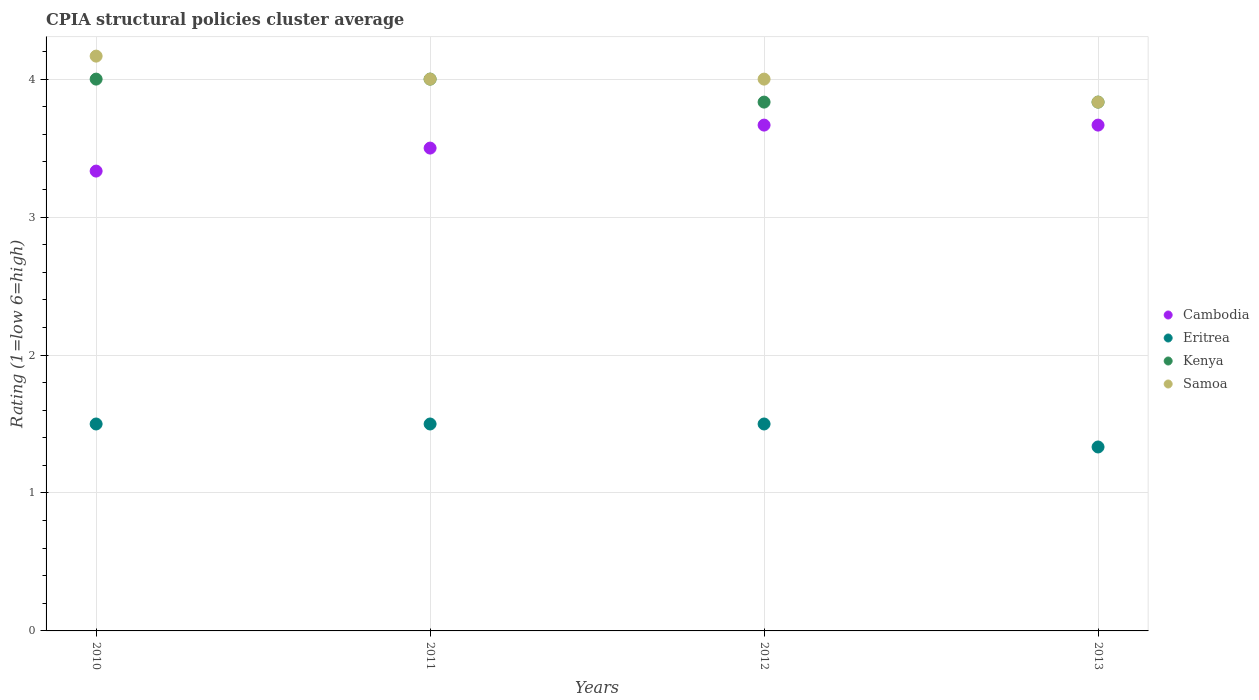How many different coloured dotlines are there?
Give a very brief answer. 4. Is the number of dotlines equal to the number of legend labels?
Your answer should be compact. Yes. What is the CPIA rating in Kenya in 2011?
Provide a succinct answer. 4. Across all years, what is the minimum CPIA rating in Eritrea?
Provide a short and direct response. 1.33. In which year was the CPIA rating in Cambodia maximum?
Give a very brief answer. 2012. In which year was the CPIA rating in Cambodia minimum?
Your response must be concise. 2010. What is the total CPIA rating in Kenya in the graph?
Your answer should be very brief. 15.67. What is the difference between the CPIA rating in Samoa in 2010 and that in 2013?
Your response must be concise. 0.33. What is the difference between the CPIA rating in Cambodia in 2013 and the CPIA rating in Eritrea in 2010?
Keep it short and to the point. 2.17. What is the average CPIA rating in Samoa per year?
Provide a short and direct response. 4. In the year 2012, what is the difference between the CPIA rating in Cambodia and CPIA rating in Samoa?
Give a very brief answer. -0.33. In how many years, is the CPIA rating in Cambodia greater than 0.2?
Ensure brevity in your answer.  4. What is the ratio of the CPIA rating in Samoa in 2012 to that in 2013?
Offer a terse response. 1.04. Is the difference between the CPIA rating in Cambodia in 2012 and 2013 greater than the difference between the CPIA rating in Samoa in 2012 and 2013?
Keep it short and to the point. No. What is the difference between the highest and the second highest CPIA rating in Samoa?
Keep it short and to the point. 0.17. What is the difference between the highest and the lowest CPIA rating in Cambodia?
Give a very brief answer. 0.33. Is it the case that in every year, the sum of the CPIA rating in Eritrea and CPIA rating in Samoa  is greater than the sum of CPIA rating in Kenya and CPIA rating in Cambodia?
Keep it short and to the point. No. Is it the case that in every year, the sum of the CPIA rating in Eritrea and CPIA rating in Kenya  is greater than the CPIA rating in Samoa?
Your answer should be compact. Yes. Is the CPIA rating in Cambodia strictly greater than the CPIA rating in Kenya over the years?
Give a very brief answer. No. How many dotlines are there?
Give a very brief answer. 4. How many years are there in the graph?
Offer a very short reply. 4. Does the graph contain any zero values?
Offer a very short reply. No. Where does the legend appear in the graph?
Offer a very short reply. Center right. How many legend labels are there?
Offer a terse response. 4. How are the legend labels stacked?
Give a very brief answer. Vertical. What is the title of the graph?
Provide a short and direct response. CPIA structural policies cluster average. What is the Rating (1=low 6=high) in Cambodia in 2010?
Your answer should be very brief. 3.33. What is the Rating (1=low 6=high) of Eritrea in 2010?
Keep it short and to the point. 1.5. What is the Rating (1=low 6=high) of Kenya in 2010?
Offer a very short reply. 4. What is the Rating (1=low 6=high) in Samoa in 2010?
Make the answer very short. 4.17. What is the Rating (1=low 6=high) in Cambodia in 2011?
Provide a short and direct response. 3.5. What is the Rating (1=low 6=high) of Cambodia in 2012?
Your answer should be very brief. 3.67. What is the Rating (1=low 6=high) in Eritrea in 2012?
Provide a short and direct response. 1.5. What is the Rating (1=low 6=high) in Kenya in 2012?
Offer a terse response. 3.83. What is the Rating (1=low 6=high) of Samoa in 2012?
Keep it short and to the point. 4. What is the Rating (1=low 6=high) in Cambodia in 2013?
Ensure brevity in your answer.  3.67. What is the Rating (1=low 6=high) of Eritrea in 2013?
Give a very brief answer. 1.33. What is the Rating (1=low 6=high) of Kenya in 2013?
Make the answer very short. 3.83. What is the Rating (1=low 6=high) in Samoa in 2013?
Provide a short and direct response. 3.83. Across all years, what is the maximum Rating (1=low 6=high) of Cambodia?
Provide a succinct answer. 3.67. Across all years, what is the maximum Rating (1=low 6=high) in Samoa?
Offer a terse response. 4.17. Across all years, what is the minimum Rating (1=low 6=high) of Cambodia?
Offer a terse response. 3.33. Across all years, what is the minimum Rating (1=low 6=high) of Eritrea?
Your response must be concise. 1.33. Across all years, what is the minimum Rating (1=low 6=high) in Kenya?
Ensure brevity in your answer.  3.83. Across all years, what is the minimum Rating (1=low 6=high) of Samoa?
Keep it short and to the point. 3.83. What is the total Rating (1=low 6=high) in Cambodia in the graph?
Keep it short and to the point. 14.17. What is the total Rating (1=low 6=high) in Eritrea in the graph?
Your answer should be compact. 5.83. What is the total Rating (1=low 6=high) of Kenya in the graph?
Give a very brief answer. 15.67. What is the total Rating (1=low 6=high) in Samoa in the graph?
Offer a very short reply. 16. What is the difference between the Rating (1=low 6=high) in Cambodia in 2010 and that in 2011?
Provide a short and direct response. -0.17. What is the difference between the Rating (1=low 6=high) in Eritrea in 2010 and that in 2011?
Provide a short and direct response. 0. What is the difference between the Rating (1=low 6=high) in Samoa in 2010 and that in 2011?
Offer a terse response. 0.17. What is the difference between the Rating (1=low 6=high) of Cambodia in 2010 and that in 2012?
Provide a succinct answer. -0.33. What is the difference between the Rating (1=low 6=high) in Eritrea in 2010 and that in 2012?
Provide a succinct answer. 0. What is the difference between the Rating (1=low 6=high) of Samoa in 2010 and that in 2012?
Offer a very short reply. 0.17. What is the difference between the Rating (1=low 6=high) in Cambodia in 2010 and that in 2013?
Offer a terse response. -0.33. What is the difference between the Rating (1=low 6=high) of Kenya in 2010 and that in 2013?
Ensure brevity in your answer.  0.17. What is the difference between the Rating (1=low 6=high) in Cambodia in 2011 and that in 2012?
Keep it short and to the point. -0.17. What is the difference between the Rating (1=low 6=high) of Cambodia in 2011 and that in 2013?
Make the answer very short. -0.17. What is the difference between the Rating (1=low 6=high) in Eritrea in 2011 and that in 2013?
Your answer should be compact. 0.17. What is the difference between the Rating (1=low 6=high) in Kenya in 2011 and that in 2013?
Provide a succinct answer. 0.17. What is the difference between the Rating (1=low 6=high) of Samoa in 2011 and that in 2013?
Make the answer very short. 0.17. What is the difference between the Rating (1=low 6=high) of Cambodia in 2012 and that in 2013?
Provide a succinct answer. 0. What is the difference between the Rating (1=low 6=high) of Kenya in 2012 and that in 2013?
Offer a very short reply. 0. What is the difference between the Rating (1=low 6=high) in Cambodia in 2010 and the Rating (1=low 6=high) in Eritrea in 2011?
Offer a very short reply. 1.83. What is the difference between the Rating (1=low 6=high) in Cambodia in 2010 and the Rating (1=low 6=high) in Samoa in 2011?
Your response must be concise. -0.67. What is the difference between the Rating (1=low 6=high) of Eritrea in 2010 and the Rating (1=low 6=high) of Kenya in 2011?
Give a very brief answer. -2.5. What is the difference between the Rating (1=low 6=high) in Eritrea in 2010 and the Rating (1=low 6=high) in Samoa in 2011?
Your answer should be very brief. -2.5. What is the difference between the Rating (1=low 6=high) in Cambodia in 2010 and the Rating (1=low 6=high) in Eritrea in 2012?
Offer a very short reply. 1.83. What is the difference between the Rating (1=low 6=high) of Eritrea in 2010 and the Rating (1=low 6=high) of Kenya in 2012?
Give a very brief answer. -2.33. What is the difference between the Rating (1=low 6=high) in Kenya in 2010 and the Rating (1=low 6=high) in Samoa in 2012?
Offer a terse response. 0. What is the difference between the Rating (1=low 6=high) in Cambodia in 2010 and the Rating (1=low 6=high) in Eritrea in 2013?
Give a very brief answer. 2. What is the difference between the Rating (1=low 6=high) in Cambodia in 2010 and the Rating (1=low 6=high) in Samoa in 2013?
Provide a short and direct response. -0.5. What is the difference between the Rating (1=low 6=high) in Eritrea in 2010 and the Rating (1=low 6=high) in Kenya in 2013?
Provide a short and direct response. -2.33. What is the difference between the Rating (1=low 6=high) of Eritrea in 2010 and the Rating (1=low 6=high) of Samoa in 2013?
Your answer should be compact. -2.33. What is the difference between the Rating (1=low 6=high) of Kenya in 2010 and the Rating (1=low 6=high) of Samoa in 2013?
Keep it short and to the point. 0.17. What is the difference between the Rating (1=low 6=high) in Eritrea in 2011 and the Rating (1=low 6=high) in Kenya in 2012?
Give a very brief answer. -2.33. What is the difference between the Rating (1=low 6=high) in Eritrea in 2011 and the Rating (1=low 6=high) in Samoa in 2012?
Provide a short and direct response. -2.5. What is the difference between the Rating (1=low 6=high) of Cambodia in 2011 and the Rating (1=low 6=high) of Eritrea in 2013?
Provide a succinct answer. 2.17. What is the difference between the Rating (1=low 6=high) in Cambodia in 2011 and the Rating (1=low 6=high) in Samoa in 2013?
Give a very brief answer. -0.33. What is the difference between the Rating (1=low 6=high) of Eritrea in 2011 and the Rating (1=low 6=high) of Kenya in 2013?
Your response must be concise. -2.33. What is the difference between the Rating (1=low 6=high) in Eritrea in 2011 and the Rating (1=low 6=high) in Samoa in 2013?
Provide a succinct answer. -2.33. What is the difference between the Rating (1=low 6=high) in Cambodia in 2012 and the Rating (1=low 6=high) in Eritrea in 2013?
Give a very brief answer. 2.33. What is the difference between the Rating (1=low 6=high) in Cambodia in 2012 and the Rating (1=low 6=high) in Kenya in 2013?
Your response must be concise. -0.17. What is the difference between the Rating (1=low 6=high) of Cambodia in 2012 and the Rating (1=low 6=high) of Samoa in 2013?
Provide a succinct answer. -0.17. What is the difference between the Rating (1=low 6=high) in Eritrea in 2012 and the Rating (1=low 6=high) in Kenya in 2013?
Keep it short and to the point. -2.33. What is the difference between the Rating (1=low 6=high) in Eritrea in 2012 and the Rating (1=low 6=high) in Samoa in 2013?
Your answer should be very brief. -2.33. What is the average Rating (1=low 6=high) in Cambodia per year?
Keep it short and to the point. 3.54. What is the average Rating (1=low 6=high) in Eritrea per year?
Give a very brief answer. 1.46. What is the average Rating (1=low 6=high) in Kenya per year?
Ensure brevity in your answer.  3.92. What is the average Rating (1=low 6=high) in Samoa per year?
Keep it short and to the point. 4. In the year 2010, what is the difference between the Rating (1=low 6=high) in Cambodia and Rating (1=low 6=high) in Eritrea?
Make the answer very short. 1.83. In the year 2010, what is the difference between the Rating (1=low 6=high) of Eritrea and Rating (1=low 6=high) of Kenya?
Offer a terse response. -2.5. In the year 2010, what is the difference between the Rating (1=low 6=high) of Eritrea and Rating (1=low 6=high) of Samoa?
Offer a very short reply. -2.67. In the year 2011, what is the difference between the Rating (1=low 6=high) of Cambodia and Rating (1=low 6=high) of Samoa?
Make the answer very short. -0.5. In the year 2011, what is the difference between the Rating (1=low 6=high) in Eritrea and Rating (1=low 6=high) in Kenya?
Your response must be concise. -2.5. In the year 2012, what is the difference between the Rating (1=low 6=high) of Cambodia and Rating (1=low 6=high) of Eritrea?
Your response must be concise. 2.17. In the year 2012, what is the difference between the Rating (1=low 6=high) in Cambodia and Rating (1=low 6=high) in Kenya?
Ensure brevity in your answer.  -0.17. In the year 2012, what is the difference between the Rating (1=low 6=high) of Eritrea and Rating (1=low 6=high) of Kenya?
Provide a succinct answer. -2.33. In the year 2012, what is the difference between the Rating (1=low 6=high) in Kenya and Rating (1=low 6=high) in Samoa?
Keep it short and to the point. -0.17. In the year 2013, what is the difference between the Rating (1=low 6=high) of Cambodia and Rating (1=low 6=high) of Eritrea?
Provide a short and direct response. 2.33. In the year 2013, what is the difference between the Rating (1=low 6=high) in Cambodia and Rating (1=low 6=high) in Samoa?
Your answer should be compact. -0.17. What is the ratio of the Rating (1=low 6=high) of Cambodia in 2010 to that in 2011?
Your response must be concise. 0.95. What is the ratio of the Rating (1=low 6=high) in Eritrea in 2010 to that in 2011?
Keep it short and to the point. 1. What is the ratio of the Rating (1=low 6=high) of Kenya in 2010 to that in 2011?
Make the answer very short. 1. What is the ratio of the Rating (1=low 6=high) in Samoa in 2010 to that in 2011?
Offer a terse response. 1.04. What is the ratio of the Rating (1=low 6=high) in Cambodia in 2010 to that in 2012?
Provide a succinct answer. 0.91. What is the ratio of the Rating (1=low 6=high) of Kenya in 2010 to that in 2012?
Make the answer very short. 1.04. What is the ratio of the Rating (1=low 6=high) in Samoa in 2010 to that in 2012?
Keep it short and to the point. 1.04. What is the ratio of the Rating (1=low 6=high) in Kenya in 2010 to that in 2013?
Ensure brevity in your answer.  1.04. What is the ratio of the Rating (1=low 6=high) of Samoa in 2010 to that in 2013?
Your answer should be very brief. 1.09. What is the ratio of the Rating (1=low 6=high) of Cambodia in 2011 to that in 2012?
Keep it short and to the point. 0.95. What is the ratio of the Rating (1=low 6=high) in Kenya in 2011 to that in 2012?
Your answer should be very brief. 1.04. What is the ratio of the Rating (1=low 6=high) of Cambodia in 2011 to that in 2013?
Offer a very short reply. 0.95. What is the ratio of the Rating (1=low 6=high) of Kenya in 2011 to that in 2013?
Your response must be concise. 1.04. What is the ratio of the Rating (1=low 6=high) in Samoa in 2011 to that in 2013?
Offer a terse response. 1.04. What is the ratio of the Rating (1=low 6=high) in Eritrea in 2012 to that in 2013?
Your answer should be very brief. 1.12. What is the ratio of the Rating (1=low 6=high) in Kenya in 2012 to that in 2013?
Make the answer very short. 1. What is the ratio of the Rating (1=low 6=high) of Samoa in 2012 to that in 2013?
Offer a terse response. 1.04. What is the difference between the highest and the second highest Rating (1=low 6=high) in Cambodia?
Provide a succinct answer. 0. What is the difference between the highest and the second highest Rating (1=low 6=high) in Samoa?
Your answer should be very brief. 0.17. What is the difference between the highest and the lowest Rating (1=low 6=high) of Cambodia?
Your response must be concise. 0.33. 